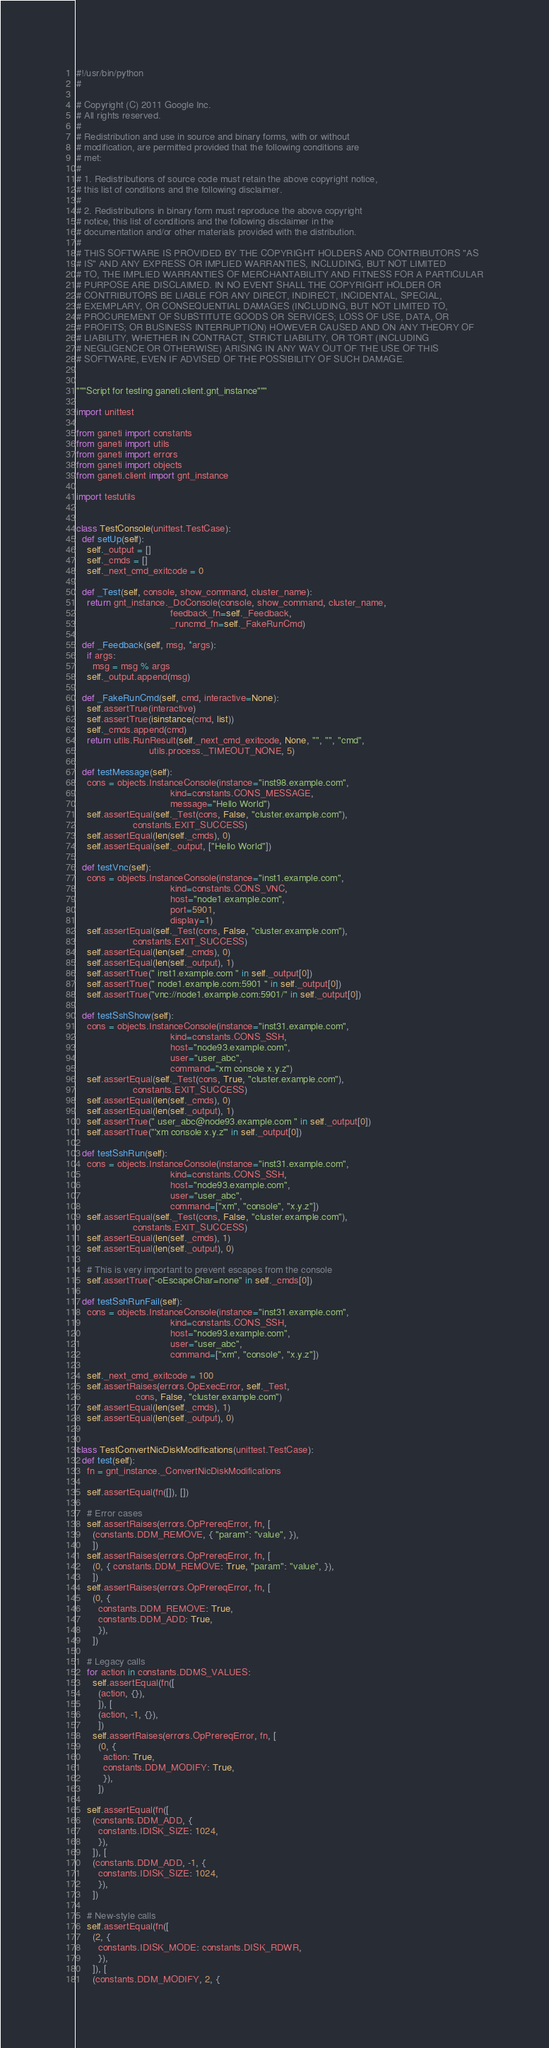Convert code to text. <code><loc_0><loc_0><loc_500><loc_500><_Python_>#!/usr/bin/python
#

# Copyright (C) 2011 Google Inc.
# All rights reserved.
#
# Redistribution and use in source and binary forms, with or without
# modification, are permitted provided that the following conditions are
# met:
#
# 1. Redistributions of source code must retain the above copyright notice,
# this list of conditions and the following disclaimer.
#
# 2. Redistributions in binary form must reproduce the above copyright
# notice, this list of conditions and the following disclaimer in the
# documentation and/or other materials provided with the distribution.
#
# THIS SOFTWARE IS PROVIDED BY THE COPYRIGHT HOLDERS AND CONTRIBUTORS "AS
# IS" AND ANY EXPRESS OR IMPLIED WARRANTIES, INCLUDING, BUT NOT LIMITED
# TO, THE IMPLIED WARRANTIES OF MERCHANTABILITY AND FITNESS FOR A PARTICULAR
# PURPOSE ARE DISCLAIMED. IN NO EVENT SHALL THE COPYRIGHT HOLDER OR
# CONTRIBUTORS BE LIABLE FOR ANY DIRECT, INDIRECT, INCIDENTAL, SPECIAL,
# EXEMPLARY, OR CONSEQUENTIAL DAMAGES (INCLUDING, BUT NOT LIMITED TO,
# PROCUREMENT OF SUBSTITUTE GOODS OR SERVICES; LOSS OF USE, DATA, OR
# PROFITS; OR BUSINESS INTERRUPTION) HOWEVER CAUSED AND ON ANY THEORY OF
# LIABILITY, WHETHER IN CONTRACT, STRICT LIABILITY, OR TORT (INCLUDING
# NEGLIGENCE OR OTHERWISE) ARISING IN ANY WAY OUT OF THE USE OF THIS
# SOFTWARE, EVEN IF ADVISED OF THE POSSIBILITY OF SUCH DAMAGE.


"""Script for testing ganeti.client.gnt_instance"""

import unittest

from ganeti import constants
from ganeti import utils
from ganeti import errors
from ganeti import objects
from ganeti.client import gnt_instance

import testutils


class TestConsole(unittest.TestCase):
  def setUp(self):
    self._output = []
    self._cmds = []
    self._next_cmd_exitcode = 0

  def _Test(self, console, show_command, cluster_name):
    return gnt_instance._DoConsole(console, show_command, cluster_name,
                                   feedback_fn=self._Feedback,
                                   _runcmd_fn=self._FakeRunCmd)

  def _Feedback(self, msg, *args):
    if args:
      msg = msg % args
    self._output.append(msg)

  def _FakeRunCmd(self, cmd, interactive=None):
    self.assertTrue(interactive)
    self.assertTrue(isinstance(cmd, list))
    self._cmds.append(cmd)
    return utils.RunResult(self._next_cmd_exitcode, None, "", "", "cmd",
                           utils.process._TIMEOUT_NONE, 5)

  def testMessage(self):
    cons = objects.InstanceConsole(instance="inst98.example.com",
                                   kind=constants.CONS_MESSAGE,
                                   message="Hello World")
    self.assertEqual(self._Test(cons, False, "cluster.example.com"),
                     constants.EXIT_SUCCESS)
    self.assertEqual(len(self._cmds), 0)
    self.assertEqual(self._output, ["Hello World"])

  def testVnc(self):
    cons = objects.InstanceConsole(instance="inst1.example.com",
                                   kind=constants.CONS_VNC,
                                   host="node1.example.com",
                                   port=5901,
                                   display=1)
    self.assertEqual(self._Test(cons, False, "cluster.example.com"),
                     constants.EXIT_SUCCESS)
    self.assertEqual(len(self._cmds), 0)
    self.assertEqual(len(self._output), 1)
    self.assertTrue(" inst1.example.com " in self._output[0])
    self.assertTrue(" node1.example.com:5901 " in self._output[0])
    self.assertTrue("vnc://node1.example.com:5901/" in self._output[0])

  def testSshShow(self):
    cons = objects.InstanceConsole(instance="inst31.example.com",
                                   kind=constants.CONS_SSH,
                                   host="node93.example.com",
                                   user="user_abc",
                                   command="xm console x.y.z")
    self.assertEqual(self._Test(cons, True, "cluster.example.com"),
                     constants.EXIT_SUCCESS)
    self.assertEqual(len(self._cmds), 0)
    self.assertEqual(len(self._output), 1)
    self.assertTrue(" user_abc@node93.example.com " in self._output[0])
    self.assertTrue("'xm console x.y.z'" in self._output[0])

  def testSshRun(self):
    cons = objects.InstanceConsole(instance="inst31.example.com",
                                   kind=constants.CONS_SSH,
                                   host="node93.example.com",
                                   user="user_abc",
                                   command=["xm", "console", "x.y.z"])
    self.assertEqual(self._Test(cons, False, "cluster.example.com"),
                     constants.EXIT_SUCCESS)
    self.assertEqual(len(self._cmds), 1)
    self.assertEqual(len(self._output), 0)

    # This is very important to prevent escapes from the console
    self.assertTrue("-oEscapeChar=none" in self._cmds[0])

  def testSshRunFail(self):
    cons = objects.InstanceConsole(instance="inst31.example.com",
                                   kind=constants.CONS_SSH,
                                   host="node93.example.com",
                                   user="user_abc",
                                   command=["xm", "console", "x.y.z"])

    self._next_cmd_exitcode = 100
    self.assertRaises(errors.OpExecError, self._Test,
                      cons, False, "cluster.example.com")
    self.assertEqual(len(self._cmds), 1)
    self.assertEqual(len(self._output), 0)


class TestConvertNicDiskModifications(unittest.TestCase):
  def test(self):
    fn = gnt_instance._ConvertNicDiskModifications

    self.assertEqual(fn([]), [])

    # Error cases
    self.assertRaises(errors.OpPrereqError, fn, [
      (constants.DDM_REMOVE, { "param": "value", }),
      ])
    self.assertRaises(errors.OpPrereqError, fn, [
      (0, { constants.DDM_REMOVE: True, "param": "value", }),
      ])
    self.assertRaises(errors.OpPrereqError, fn, [
      (0, {
        constants.DDM_REMOVE: True,
        constants.DDM_ADD: True,
        }),
      ])

    # Legacy calls
    for action in constants.DDMS_VALUES:
      self.assertEqual(fn([
        (action, {}),
        ]), [
        (action, -1, {}),
        ])
      self.assertRaises(errors.OpPrereqError, fn, [
        (0, {
          action: True,
          constants.DDM_MODIFY: True,
          }),
        ])

    self.assertEqual(fn([
      (constants.DDM_ADD, {
        constants.IDISK_SIZE: 1024,
        }),
      ]), [
      (constants.DDM_ADD, -1, {
        constants.IDISK_SIZE: 1024,
        }),
      ])

    # New-style calls
    self.assertEqual(fn([
      (2, {
        constants.IDISK_MODE: constants.DISK_RDWR,
        }),
      ]), [
      (constants.DDM_MODIFY, 2, {</code> 